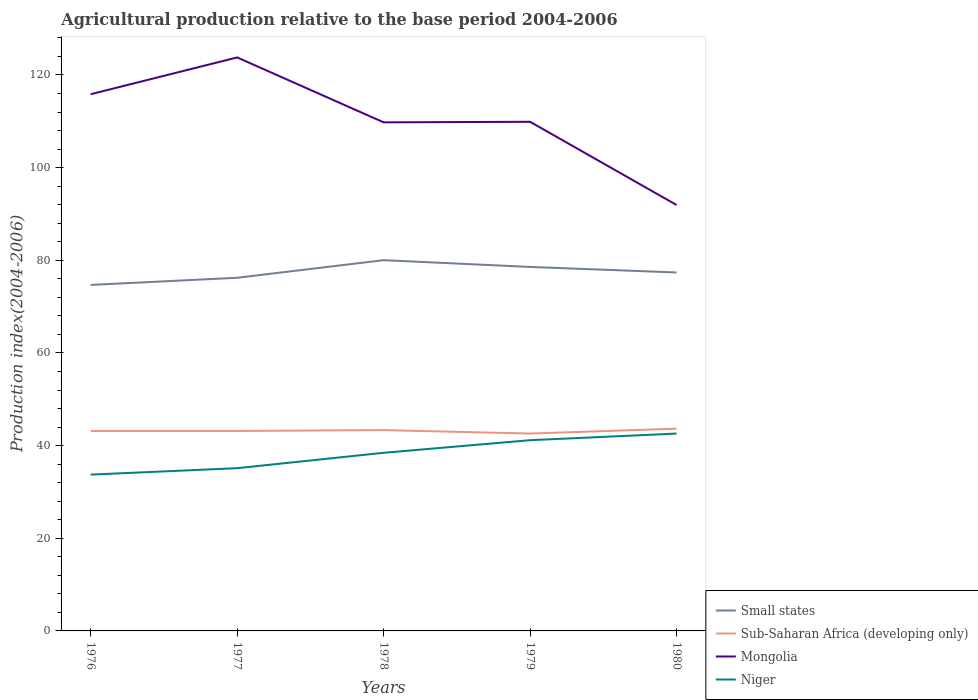How many different coloured lines are there?
Keep it short and to the point. 4. Does the line corresponding to Sub-Saharan Africa (developing only) intersect with the line corresponding to Niger?
Provide a short and direct response. No. Across all years, what is the maximum agricultural production index in Mongolia?
Make the answer very short. 91.94. In which year was the agricultural production index in Mongolia maximum?
Make the answer very short. 1980. What is the total agricultural production index in Niger in the graph?
Give a very brief answer. -6.04. What is the difference between the highest and the second highest agricultural production index in Small states?
Your response must be concise. 5.34. What is the difference between the highest and the lowest agricultural production index in Small states?
Provide a short and direct response. 2. Is the agricultural production index in Small states strictly greater than the agricultural production index in Niger over the years?
Offer a terse response. No. How many lines are there?
Provide a succinct answer. 4. How many years are there in the graph?
Provide a short and direct response. 5. What is the difference between two consecutive major ticks on the Y-axis?
Ensure brevity in your answer.  20. Are the values on the major ticks of Y-axis written in scientific E-notation?
Provide a short and direct response. No. Does the graph contain any zero values?
Keep it short and to the point. No. Does the graph contain grids?
Make the answer very short. No. How are the legend labels stacked?
Give a very brief answer. Vertical. What is the title of the graph?
Give a very brief answer. Agricultural production relative to the base period 2004-2006. Does "Mauritius" appear as one of the legend labels in the graph?
Provide a succinct answer. No. What is the label or title of the X-axis?
Provide a short and direct response. Years. What is the label or title of the Y-axis?
Your answer should be compact. Production index(2004-2006). What is the Production index(2004-2006) in Small states in 1976?
Provide a short and direct response. 74.69. What is the Production index(2004-2006) of Sub-Saharan Africa (developing only) in 1976?
Offer a terse response. 43.17. What is the Production index(2004-2006) in Mongolia in 1976?
Your response must be concise. 115.85. What is the Production index(2004-2006) in Niger in 1976?
Ensure brevity in your answer.  33.74. What is the Production index(2004-2006) in Small states in 1977?
Your answer should be compact. 76.23. What is the Production index(2004-2006) in Sub-Saharan Africa (developing only) in 1977?
Provide a succinct answer. 43.16. What is the Production index(2004-2006) in Mongolia in 1977?
Provide a short and direct response. 123.79. What is the Production index(2004-2006) of Niger in 1977?
Offer a very short reply. 35.13. What is the Production index(2004-2006) in Small states in 1978?
Offer a terse response. 80.03. What is the Production index(2004-2006) of Sub-Saharan Africa (developing only) in 1978?
Keep it short and to the point. 43.35. What is the Production index(2004-2006) of Mongolia in 1978?
Offer a terse response. 109.78. What is the Production index(2004-2006) of Niger in 1978?
Your answer should be very brief. 38.45. What is the Production index(2004-2006) of Small states in 1979?
Your response must be concise. 78.57. What is the Production index(2004-2006) of Sub-Saharan Africa (developing only) in 1979?
Ensure brevity in your answer.  42.6. What is the Production index(2004-2006) in Mongolia in 1979?
Ensure brevity in your answer.  109.9. What is the Production index(2004-2006) in Niger in 1979?
Make the answer very short. 41.17. What is the Production index(2004-2006) in Small states in 1980?
Provide a succinct answer. 77.37. What is the Production index(2004-2006) of Sub-Saharan Africa (developing only) in 1980?
Offer a terse response. 43.65. What is the Production index(2004-2006) of Mongolia in 1980?
Your response must be concise. 91.94. What is the Production index(2004-2006) of Niger in 1980?
Make the answer very short. 42.6. Across all years, what is the maximum Production index(2004-2006) of Small states?
Your answer should be compact. 80.03. Across all years, what is the maximum Production index(2004-2006) of Sub-Saharan Africa (developing only)?
Offer a terse response. 43.65. Across all years, what is the maximum Production index(2004-2006) in Mongolia?
Keep it short and to the point. 123.79. Across all years, what is the maximum Production index(2004-2006) of Niger?
Make the answer very short. 42.6. Across all years, what is the minimum Production index(2004-2006) of Small states?
Your response must be concise. 74.69. Across all years, what is the minimum Production index(2004-2006) of Sub-Saharan Africa (developing only)?
Provide a succinct answer. 42.6. Across all years, what is the minimum Production index(2004-2006) in Mongolia?
Give a very brief answer. 91.94. Across all years, what is the minimum Production index(2004-2006) in Niger?
Offer a terse response. 33.74. What is the total Production index(2004-2006) of Small states in the graph?
Your response must be concise. 386.88. What is the total Production index(2004-2006) of Sub-Saharan Africa (developing only) in the graph?
Your response must be concise. 215.94. What is the total Production index(2004-2006) in Mongolia in the graph?
Offer a very short reply. 551.26. What is the total Production index(2004-2006) in Niger in the graph?
Your response must be concise. 191.09. What is the difference between the Production index(2004-2006) of Small states in 1976 and that in 1977?
Provide a succinct answer. -1.55. What is the difference between the Production index(2004-2006) in Sub-Saharan Africa (developing only) in 1976 and that in 1977?
Your answer should be compact. 0. What is the difference between the Production index(2004-2006) of Mongolia in 1976 and that in 1977?
Offer a very short reply. -7.94. What is the difference between the Production index(2004-2006) of Niger in 1976 and that in 1977?
Offer a very short reply. -1.39. What is the difference between the Production index(2004-2006) of Small states in 1976 and that in 1978?
Provide a succinct answer. -5.34. What is the difference between the Production index(2004-2006) in Sub-Saharan Africa (developing only) in 1976 and that in 1978?
Give a very brief answer. -0.18. What is the difference between the Production index(2004-2006) in Mongolia in 1976 and that in 1978?
Your answer should be very brief. 6.07. What is the difference between the Production index(2004-2006) in Niger in 1976 and that in 1978?
Offer a very short reply. -4.71. What is the difference between the Production index(2004-2006) of Small states in 1976 and that in 1979?
Give a very brief answer. -3.88. What is the difference between the Production index(2004-2006) of Sub-Saharan Africa (developing only) in 1976 and that in 1979?
Make the answer very short. 0.56. What is the difference between the Production index(2004-2006) in Mongolia in 1976 and that in 1979?
Your response must be concise. 5.95. What is the difference between the Production index(2004-2006) of Niger in 1976 and that in 1979?
Provide a succinct answer. -7.43. What is the difference between the Production index(2004-2006) in Small states in 1976 and that in 1980?
Your answer should be compact. -2.69. What is the difference between the Production index(2004-2006) in Sub-Saharan Africa (developing only) in 1976 and that in 1980?
Your response must be concise. -0.49. What is the difference between the Production index(2004-2006) of Mongolia in 1976 and that in 1980?
Make the answer very short. 23.91. What is the difference between the Production index(2004-2006) of Niger in 1976 and that in 1980?
Provide a short and direct response. -8.86. What is the difference between the Production index(2004-2006) in Small states in 1977 and that in 1978?
Offer a terse response. -3.8. What is the difference between the Production index(2004-2006) of Sub-Saharan Africa (developing only) in 1977 and that in 1978?
Provide a short and direct response. -0.18. What is the difference between the Production index(2004-2006) in Mongolia in 1977 and that in 1978?
Keep it short and to the point. 14.01. What is the difference between the Production index(2004-2006) in Niger in 1977 and that in 1978?
Your answer should be compact. -3.32. What is the difference between the Production index(2004-2006) in Small states in 1977 and that in 1979?
Make the answer very short. -2.34. What is the difference between the Production index(2004-2006) of Sub-Saharan Africa (developing only) in 1977 and that in 1979?
Give a very brief answer. 0.56. What is the difference between the Production index(2004-2006) of Mongolia in 1977 and that in 1979?
Give a very brief answer. 13.89. What is the difference between the Production index(2004-2006) of Niger in 1977 and that in 1979?
Keep it short and to the point. -6.04. What is the difference between the Production index(2004-2006) in Small states in 1977 and that in 1980?
Ensure brevity in your answer.  -1.14. What is the difference between the Production index(2004-2006) of Sub-Saharan Africa (developing only) in 1977 and that in 1980?
Your answer should be very brief. -0.49. What is the difference between the Production index(2004-2006) of Mongolia in 1977 and that in 1980?
Your answer should be compact. 31.85. What is the difference between the Production index(2004-2006) of Niger in 1977 and that in 1980?
Offer a terse response. -7.47. What is the difference between the Production index(2004-2006) of Small states in 1978 and that in 1979?
Ensure brevity in your answer.  1.46. What is the difference between the Production index(2004-2006) in Sub-Saharan Africa (developing only) in 1978 and that in 1979?
Keep it short and to the point. 0.74. What is the difference between the Production index(2004-2006) of Mongolia in 1978 and that in 1979?
Offer a terse response. -0.12. What is the difference between the Production index(2004-2006) in Niger in 1978 and that in 1979?
Your answer should be compact. -2.72. What is the difference between the Production index(2004-2006) of Small states in 1978 and that in 1980?
Provide a succinct answer. 2.65. What is the difference between the Production index(2004-2006) of Sub-Saharan Africa (developing only) in 1978 and that in 1980?
Offer a very short reply. -0.31. What is the difference between the Production index(2004-2006) in Mongolia in 1978 and that in 1980?
Make the answer very short. 17.84. What is the difference between the Production index(2004-2006) in Niger in 1978 and that in 1980?
Your answer should be compact. -4.15. What is the difference between the Production index(2004-2006) in Small states in 1979 and that in 1980?
Ensure brevity in your answer.  1.2. What is the difference between the Production index(2004-2006) in Sub-Saharan Africa (developing only) in 1979 and that in 1980?
Keep it short and to the point. -1.05. What is the difference between the Production index(2004-2006) in Mongolia in 1979 and that in 1980?
Provide a short and direct response. 17.96. What is the difference between the Production index(2004-2006) of Niger in 1979 and that in 1980?
Make the answer very short. -1.43. What is the difference between the Production index(2004-2006) of Small states in 1976 and the Production index(2004-2006) of Sub-Saharan Africa (developing only) in 1977?
Ensure brevity in your answer.  31.52. What is the difference between the Production index(2004-2006) in Small states in 1976 and the Production index(2004-2006) in Mongolia in 1977?
Your answer should be very brief. -49.1. What is the difference between the Production index(2004-2006) of Small states in 1976 and the Production index(2004-2006) of Niger in 1977?
Offer a very short reply. 39.56. What is the difference between the Production index(2004-2006) of Sub-Saharan Africa (developing only) in 1976 and the Production index(2004-2006) of Mongolia in 1977?
Your answer should be compact. -80.62. What is the difference between the Production index(2004-2006) of Sub-Saharan Africa (developing only) in 1976 and the Production index(2004-2006) of Niger in 1977?
Give a very brief answer. 8.04. What is the difference between the Production index(2004-2006) of Mongolia in 1976 and the Production index(2004-2006) of Niger in 1977?
Provide a succinct answer. 80.72. What is the difference between the Production index(2004-2006) in Small states in 1976 and the Production index(2004-2006) in Sub-Saharan Africa (developing only) in 1978?
Offer a terse response. 31.34. What is the difference between the Production index(2004-2006) in Small states in 1976 and the Production index(2004-2006) in Mongolia in 1978?
Ensure brevity in your answer.  -35.09. What is the difference between the Production index(2004-2006) of Small states in 1976 and the Production index(2004-2006) of Niger in 1978?
Offer a terse response. 36.24. What is the difference between the Production index(2004-2006) of Sub-Saharan Africa (developing only) in 1976 and the Production index(2004-2006) of Mongolia in 1978?
Your answer should be compact. -66.61. What is the difference between the Production index(2004-2006) of Sub-Saharan Africa (developing only) in 1976 and the Production index(2004-2006) of Niger in 1978?
Keep it short and to the point. 4.72. What is the difference between the Production index(2004-2006) in Mongolia in 1976 and the Production index(2004-2006) in Niger in 1978?
Your response must be concise. 77.4. What is the difference between the Production index(2004-2006) in Small states in 1976 and the Production index(2004-2006) in Sub-Saharan Africa (developing only) in 1979?
Provide a short and direct response. 32.08. What is the difference between the Production index(2004-2006) in Small states in 1976 and the Production index(2004-2006) in Mongolia in 1979?
Offer a terse response. -35.21. What is the difference between the Production index(2004-2006) in Small states in 1976 and the Production index(2004-2006) in Niger in 1979?
Provide a succinct answer. 33.52. What is the difference between the Production index(2004-2006) of Sub-Saharan Africa (developing only) in 1976 and the Production index(2004-2006) of Mongolia in 1979?
Give a very brief answer. -66.73. What is the difference between the Production index(2004-2006) of Sub-Saharan Africa (developing only) in 1976 and the Production index(2004-2006) of Niger in 1979?
Your answer should be very brief. 2. What is the difference between the Production index(2004-2006) of Mongolia in 1976 and the Production index(2004-2006) of Niger in 1979?
Ensure brevity in your answer.  74.68. What is the difference between the Production index(2004-2006) in Small states in 1976 and the Production index(2004-2006) in Sub-Saharan Africa (developing only) in 1980?
Provide a short and direct response. 31.03. What is the difference between the Production index(2004-2006) in Small states in 1976 and the Production index(2004-2006) in Mongolia in 1980?
Ensure brevity in your answer.  -17.25. What is the difference between the Production index(2004-2006) in Small states in 1976 and the Production index(2004-2006) in Niger in 1980?
Provide a short and direct response. 32.09. What is the difference between the Production index(2004-2006) of Sub-Saharan Africa (developing only) in 1976 and the Production index(2004-2006) of Mongolia in 1980?
Keep it short and to the point. -48.77. What is the difference between the Production index(2004-2006) of Sub-Saharan Africa (developing only) in 1976 and the Production index(2004-2006) of Niger in 1980?
Provide a short and direct response. 0.57. What is the difference between the Production index(2004-2006) of Mongolia in 1976 and the Production index(2004-2006) of Niger in 1980?
Your answer should be compact. 73.25. What is the difference between the Production index(2004-2006) in Small states in 1977 and the Production index(2004-2006) in Sub-Saharan Africa (developing only) in 1978?
Provide a succinct answer. 32.88. What is the difference between the Production index(2004-2006) of Small states in 1977 and the Production index(2004-2006) of Mongolia in 1978?
Your answer should be very brief. -33.55. What is the difference between the Production index(2004-2006) in Small states in 1977 and the Production index(2004-2006) in Niger in 1978?
Offer a terse response. 37.78. What is the difference between the Production index(2004-2006) of Sub-Saharan Africa (developing only) in 1977 and the Production index(2004-2006) of Mongolia in 1978?
Offer a terse response. -66.62. What is the difference between the Production index(2004-2006) of Sub-Saharan Africa (developing only) in 1977 and the Production index(2004-2006) of Niger in 1978?
Offer a terse response. 4.71. What is the difference between the Production index(2004-2006) in Mongolia in 1977 and the Production index(2004-2006) in Niger in 1978?
Provide a succinct answer. 85.34. What is the difference between the Production index(2004-2006) in Small states in 1977 and the Production index(2004-2006) in Sub-Saharan Africa (developing only) in 1979?
Your answer should be compact. 33.63. What is the difference between the Production index(2004-2006) in Small states in 1977 and the Production index(2004-2006) in Mongolia in 1979?
Provide a succinct answer. -33.67. What is the difference between the Production index(2004-2006) of Small states in 1977 and the Production index(2004-2006) of Niger in 1979?
Make the answer very short. 35.06. What is the difference between the Production index(2004-2006) of Sub-Saharan Africa (developing only) in 1977 and the Production index(2004-2006) of Mongolia in 1979?
Ensure brevity in your answer.  -66.74. What is the difference between the Production index(2004-2006) of Sub-Saharan Africa (developing only) in 1977 and the Production index(2004-2006) of Niger in 1979?
Offer a terse response. 1.99. What is the difference between the Production index(2004-2006) in Mongolia in 1977 and the Production index(2004-2006) in Niger in 1979?
Give a very brief answer. 82.62. What is the difference between the Production index(2004-2006) of Small states in 1977 and the Production index(2004-2006) of Sub-Saharan Africa (developing only) in 1980?
Provide a short and direct response. 32.58. What is the difference between the Production index(2004-2006) of Small states in 1977 and the Production index(2004-2006) of Mongolia in 1980?
Your response must be concise. -15.71. What is the difference between the Production index(2004-2006) in Small states in 1977 and the Production index(2004-2006) in Niger in 1980?
Keep it short and to the point. 33.63. What is the difference between the Production index(2004-2006) of Sub-Saharan Africa (developing only) in 1977 and the Production index(2004-2006) of Mongolia in 1980?
Make the answer very short. -48.78. What is the difference between the Production index(2004-2006) of Sub-Saharan Africa (developing only) in 1977 and the Production index(2004-2006) of Niger in 1980?
Offer a terse response. 0.56. What is the difference between the Production index(2004-2006) in Mongolia in 1977 and the Production index(2004-2006) in Niger in 1980?
Offer a very short reply. 81.19. What is the difference between the Production index(2004-2006) in Small states in 1978 and the Production index(2004-2006) in Sub-Saharan Africa (developing only) in 1979?
Give a very brief answer. 37.42. What is the difference between the Production index(2004-2006) in Small states in 1978 and the Production index(2004-2006) in Mongolia in 1979?
Keep it short and to the point. -29.87. What is the difference between the Production index(2004-2006) of Small states in 1978 and the Production index(2004-2006) of Niger in 1979?
Make the answer very short. 38.86. What is the difference between the Production index(2004-2006) of Sub-Saharan Africa (developing only) in 1978 and the Production index(2004-2006) of Mongolia in 1979?
Offer a very short reply. -66.55. What is the difference between the Production index(2004-2006) in Sub-Saharan Africa (developing only) in 1978 and the Production index(2004-2006) in Niger in 1979?
Offer a terse response. 2.18. What is the difference between the Production index(2004-2006) of Mongolia in 1978 and the Production index(2004-2006) of Niger in 1979?
Provide a short and direct response. 68.61. What is the difference between the Production index(2004-2006) of Small states in 1978 and the Production index(2004-2006) of Sub-Saharan Africa (developing only) in 1980?
Keep it short and to the point. 36.37. What is the difference between the Production index(2004-2006) of Small states in 1978 and the Production index(2004-2006) of Mongolia in 1980?
Offer a very short reply. -11.91. What is the difference between the Production index(2004-2006) of Small states in 1978 and the Production index(2004-2006) of Niger in 1980?
Your response must be concise. 37.43. What is the difference between the Production index(2004-2006) in Sub-Saharan Africa (developing only) in 1978 and the Production index(2004-2006) in Mongolia in 1980?
Your answer should be compact. -48.59. What is the difference between the Production index(2004-2006) in Sub-Saharan Africa (developing only) in 1978 and the Production index(2004-2006) in Niger in 1980?
Keep it short and to the point. 0.75. What is the difference between the Production index(2004-2006) in Mongolia in 1978 and the Production index(2004-2006) in Niger in 1980?
Keep it short and to the point. 67.18. What is the difference between the Production index(2004-2006) in Small states in 1979 and the Production index(2004-2006) in Sub-Saharan Africa (developing only) in 1980?
Offer a terse response. 34.91. What is the difference between the Production index(2004-2006) of Small states in 1979 and the Production index(2004-2006) of Mongolia in 1980?
Your answer should be very brief. -13.37. What is the difference between the Production index(2004-2006) of Small states in 1979 and the Production index(2004-2006) of Niger in 1980?
Provide a succinct answer. 35.97. What is the difference between the Production index(2004-2006) in Sub-Saharan Africa (developing only) in 1979 and the Production index(2004-2006) in Mongolia in 1980?
Offer a very short reply. -49.34. What is the difference between the Production index(2004-2006) of Sub-Saharan Africa (developing only) in 1979 and the Production index(2004-2006) of Niger in 1980?
Your answer should be compact. 0. What is the difference between the Production index(2004-2006) in Mongolia in 1979 and the Production index(2004-2006) in Niger in 1980?
Offer a terse response. 67.3. What is the average Production index(2004-2006) in Small states per year?
Your answer should be compact. 77.38. What is the average Production index(2004-2006) in Sub-Saharan Africa (developing only) per year?
Offer a terse response. 43.19. What is the average Production index(2004-2006) of Mongolia per year?
Provide a short and direct response. 110.25. What is the average Production index(2004-2006) of Niger per year?
Give a very brief answer. 38.22. In the year 1976, what is the difference between the Production index(2004-2006) in Small states and Production index(2004-2006) in Sub-Saharan Africa (developing only)?
Your answer should be compact. 31.52. In the year 1976, what is the difference between the Production index(2004-2006) in Small states and Production index(2004-2006) in Mongolia?
Your response must be concise. -41.16. In the year 1976, what is the difference between the Production index(2004-2006) in Small states and Production index(2004-2006) in Niger?
Your answer should be compact. 40.95. In the year 1976, what is the difference between the Production index(2004-2006) of Sub-Saharan Africa (developing only) and Production index(2004-2006) of Mongolia?
Your answer should be very brief. -72.68. In the year 1976, what is the difference between the Production index(2004-2006) in Sub-Saharan Africa (developing only) and Production index(2004-2006) in Niger?
Make the answer very short. 9.43. In the year 1976, what is the difference between the Production index(2004-2006) in Mongolia and Production index(2004-2006) in Niger?
Your answer should be compact. 82.11. In the year 1977, what is the difference between the Production index(2004-2006) in Small states and Production index(2004-2006) in Sub-Saharan Africa (developing only)?
Keep it short and to the point. 33.07. In the year 1977, what is the difference between the Production index(2004-2006) of Small states and Production index(2004-2006) of Mongolia?
Provide a succinct answer. -47.56. In the year 1977, what is the difference between the Production index(2004-2006) in Small states and Production index(2004-2006) in Niger?
Your answer should be compact. 41.1. In the year 1977, what is the difference between the Production index(2004-2006) of Sub-Saharan Africa (developing only) and Production index(2004-2006) of Mongolia?
Your response must be concise. -80.63. In the year 1977, what is the difference between the Production index(2004-2006) of Sub-Saharan Africa (developing only) and Production index(2004-2006) of Niger?
Your response must be concise. 8.03. In the year 1977, what is the difference between the Production index(2004-2006) of Mongolia and Production index(2004-2006) of Niger?
Ensure brevity in your answer.  88.66. In the year 1978, what is the difference between the Production index(2004-2006) in Small states and Production index(2004-2006) in Sub-Saharan Africa (developing only)?
Make the answer very short. 36.68. In the year 1978, what is the difference between the Production index(2004-2006) of Small states and Production index(2004-2006) of Mongolia?
Offer a very short reply. -29.75. In the year 1978, what is the difference between the Production index(2004-2006) in Small states and Production index(2004-2006) in Niger?
Ensure brevity in your answer.  41.58. In the year 1978, what is the difference between the Production index(2004-2006) of Sub-Saharan Africa (developing only) and Production index(2004-2006) of Mongolia?
Provide a succinct answer. -66.43. In the year 1978, what is the difference between the Production index(2004-2006) of Sub-Saharan Africa (developing only) and Production index(2004-2006) of Niger?
Your response must be concise. 4.9. In the year 1978, what is the difference between the Production index(2004-2006) of Mongolia and Production index(2004-2006) of Niger?
Your answer should be very brief. 71.33. In the year 1979, what is the difference between the Production index(2004-2006) in Small states and Production index(2004-2006) in Sub-Saharan Africa (developing only)?
Ensure brevity in your answer.  35.96. In the year 1979, what is the difference between the Production index(2004-2006) in Small states and Production index(2004-2006) in Mongolia?
Give a very brief answer. -31.33. In the year 1979, what is the difference between the Production index(2004-2006) of Small states and Production index(2004-2006) of Niger?
Your answer should be very brief. 37.4. In the year 1979, what is the difference between the Production index(2004-2006) in Sub-Saharan Africa (developing only) and Production index(2004-2006) in Mongolia?
Give a very brief answer. -67.3. In the year 1979, what is the difference between the Production index(2004-2006) of Sub-Saharan Africa (developing only) and Production index(2004-2006) of Niger?
Ensure brevity in your answer.  1.43. In the year 1979, what is the difference between the Production index(2004-2006) of Mongolia and Production index(2004-2006) of Niger?
Give a very brief answer. 68.73. In the year 1980, what is the difference between the Production index(2004-2006) in Small states and Production index(2004-2006) in Sub-Saharan Africa (developing only)?
Make the answer very short. 33.72. In the year 1980, what is the difference between the Production index(2004-2006) of Small states and Production index(2004-2006) of Mongolia?
Keep it short and to the point. -14.57. In the year 1980, what is the difference between the Production index(2004-2006) in Small states and Production index(2004-2006) in Niger?
Provide a succinct answer. 34.77. In the year 1980, what is the difference between the Production index(2004-2006) of Sub-Saharan Africa (developing only) and Production index(2004-2006) of Mongolia?
Ensure brevity in your answer.  -48.29. In the year 1980, what is the difference between the Production index(2004-2006) of Sub-Saharan Africa (developing only) and Production index(2004-2006) of Niger?
Make the answer very short. 1.05. In the year 1980, what is the difference between the Production index(2004-2006) of Mongolia and Production index(2004-2006) of Niger?
Keep it short and to the point. 49.34. What is the ratio of the Production index(2004-2006) in Small states in 1976 to that in 1977?
Give a very brief answer. 0.98. What is the ratio of the Production index(2004-2006) in Mongolia in 1976 to that in 1977?
Offer a very short reply. 0.94. What is the ratio of the Production index(2004-2006) of Niger in 1976 to that in 1977?
Your answer should be compact. 0.96. What is the ratio of the Production index(2004-2006) in Small states in 1976 to that in 1978?
Ensure brevity in your answer.  0.93. What is the ratio of the Production index(2004-2006) in Mongolia in 1976 to that in 1978?
Your response must be concise. 1.06. What is the ratio of the Production index(2004-2006) in Niger in 1976 to that in 1978?
Give a very brief answer. 0.88. What is the ratio of the Production index(2004-2006) in Small states in 1976 to that in 1979?
Your answer should be compact. 0.95. What is the ratio of the Production index(2004-2006) of Sub-Saharan Africa (developing only) in 1976 to that in 1979?
Your response must be concise. 1.01. What is the ratio of the Production index(2004-2006) in Mongolia in 1976 to that in 1979?
Your answer should be compact. 1.05. What is the ratio of the Production index(2004-2006) of Niger in 1976 to that in 1979?
Provide a short and direct response. 0.82. What is the ratio of the Production index(2004-2006) of Small states in 1976 to that in 1980?
Offer a very short reply. 0.97. What is the ratio of the Production index(2004-2006) in Mongolia in 1976 to that in 1980?
Your response must be concise. 1.26. What is the ratio of the Production index(2004-2006) in Niger in 1976 to that in 1980?
Ensure brevity in your answer.  0.79. What is the ratio of the Production index(2004-2006) of Small states in 1977 to that in 1978?
Your answer should be very brief. 0.95. What is the ratio of the Production index(2004-2006) in Sub-Saharan Africa (developing only) in 1977 to that in 1978?
Offer a very short reply. 1. What is the ratio of the Production index(2004-2006) of Mongolia in 1977 to that in 1978?
Your response must be concise. 1.13. What is the ratio of the Production index(2004-2006) in Niger in 1977 to that in 1978?
Ensure brevity in your answer.  0.91. What is the ratio of the Production index(2004-2006) of Small states in 1977 to that in 1979?
Your response must be concise. 0.97. What is the ratio of the Production index(2004-2006) of Sub-Saharan Africa (developing only) in 1977 to that in 1979?
Make the answer very short. 1.01. What is the ratio of the Production index(2004-2006) of Mongolia in 1977 to that in 1979?
Your answer should be very brief. 1.13. What is the ratio of the Production index(2004-2006) of Niger in 1977 to that in 1979?
Your response must be concise. 0.85. What is the ratio of the Production index(2004-2006) in Small states in 1977 to that in 1980?
Offer a terse response. 0.99. What is the ratio of the Production index(2004-2006) of Sub-Saharan Africa (developing only) in 1977 to that in 1980?
Your response must be concise. 0.99. What is the ratio of the Production index(2004-2006) of Mongolia in 1977 to that in 1980?
Your answer should be compact. 1.35. What is the ratio of the Production index(2004-2006) of Niger in 1977 to that in 1980?
Keep it short and to the point. 0.82. What is the ratio of the Production index(2004-2006) of Small states in 1978 to that in 1979?
Make the answer very short. 1.02. What is the ratio of the Production index(2004-2006) of Sub-Saharan Africa (developing only) in 1978 to that in 1979?
Make the answer very short. 1.02. What is the ratio of the Production index(2004-2006) in Mongolia in 1978 to that in 1979?
Provide a short and direct response. 1. What is the ratio of the Production index(2004-2006) in Niger in 1978 to that in 1979?
Provide a short and direct response. 0.93. What is the ratio of the Production index(2004-2006) in Small states in 1978 to that in 1980?
Your answer should be very brief. 1.03. What is the ratio of the Production index(2004-2006) of Sub-Saharan Africa (developing only) in 1978 to that in 1980?
Offer a terse response. 0.99. What is the ratio of the Production index(2004-2006) of Mongolia in 1978 to that in 1980?
Offer a very short reply. 1.19. What is the ratio of the Production index(2004-2006) in Niger in 1978 to that in 1980?
Provide a succinct answer. 0.9. What is the ratio of the Production index(2004-2006) of Small states in 1979 to that in 1980?
Make the answer very short. 1.02. What is the ratio of the Production index(2004-2006) of Sub-Saharan Africa (developing only) in 1979 to that in 1980?
Your answer should be very brief. 0.98. What is the ratio of the Production index(2004-2006) of Mongolia in 1979 to that in 1980?
Ensure brevity in your answer.  1.2. What is the ratio of the Production index(2004-2006) in Niger in 1979 to that in 1980?
Provide a succinct answer. 0.97. What is the difference between the highest and the second highest Production index(2004-2006) of Small states?
Make the answer very short. 1.46. What is the difference between the highest and the second highest Production index(2004-2006) in Sub-Saharan Africa (developing only)?
Make the answer very short. 0.31. What is the difference between the highest and the second highest Production index(2004-2006) of Mongolia?
Make the answer very short. 7.94. What is the difference between the highest and the second highest Production index(2004-2006) in Niger?
Offer a terse response. 1.43. What is the difference between the highest and the lowest Production index(2004-2006) in Small states?
Give a very brief answer. 5.34. What is the difference between the highest and the lowest Production index(2004-2006) in Sub-Saharan Africa (developing only)?
Ensure brevity in your answer.  1.05. What is the difference between the highest and the lowest Production index(2004-2006) of Mongolia?
Provide a succinct answer. 31.85. What is the difference between the highest and the lowest Production index(2004-2006) in Niger?
Your answer should be compact. 8.86. 